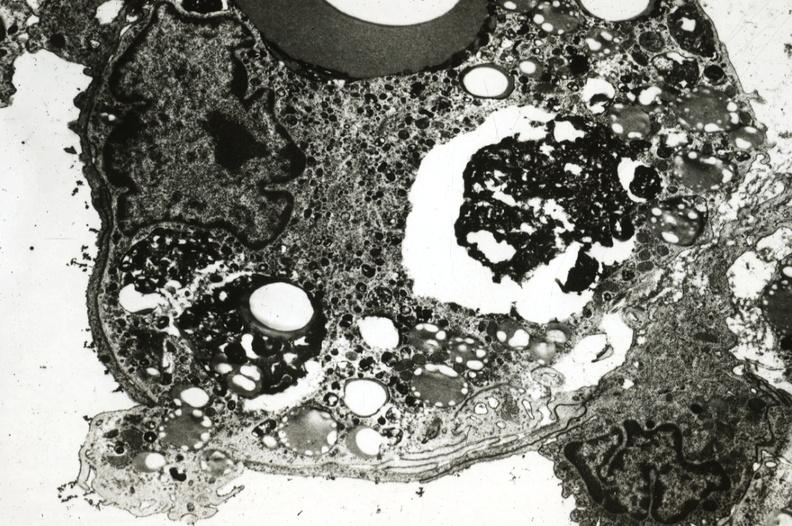where is this?
Answer the question using a single word or phrase. Aorta 